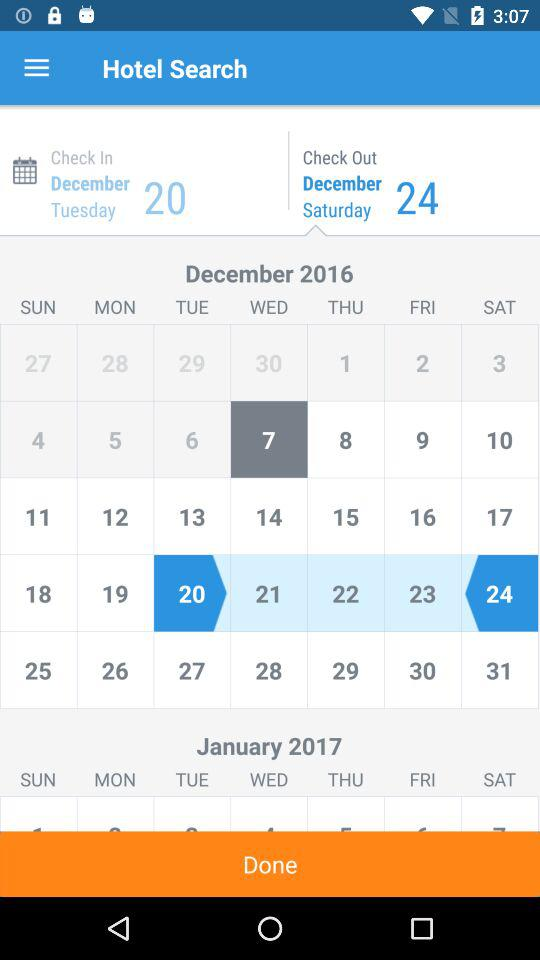How many days apart are the selected check in and check out dates?
Answer the question using a single word or phrase. 4 